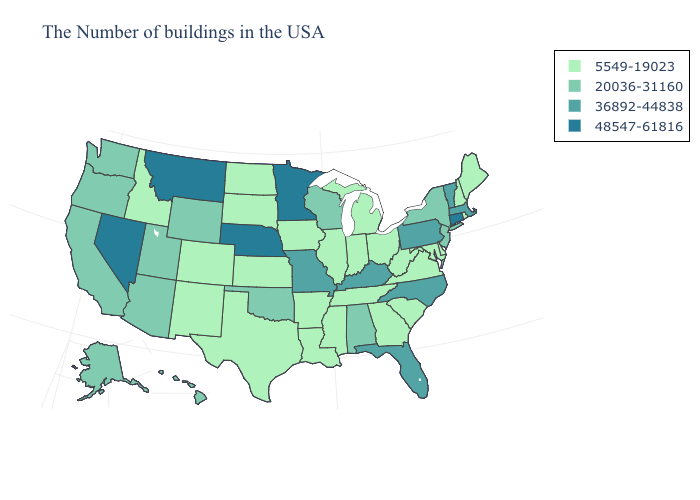Which states have the highest value in the USA?
Keep it brief. Connecticut, Minnesota, Nebraska, Montana, Nevada. What is the value of Maine?
Quick response, please. 5549-19023. Name the states that have a value in the range 36892-44838?
Keep it brief. Massachusetts, Vermont, Pennsylvania, North Carolina, Florida, Kentucky, Missouri. What is the lowest value in states that border Delaware?
Be succinct. 5549-19023. Does North Carolina have the lowest value in the South?
Be succinct. No. Which states have the lowest value in the West?
Quick response, please. Colorado, New Mexico, Idaho. Which states hav the highest value in the MidWest?
Short answer required. Minnesota, Nebraska. Name the states that have a value in the range 48547-61816?
Keep it brief. Connecticut, Minnesota, Nebraska, Montana, Nevada. Does New York have the same value as Hawaii?
Be succinct. Yes. Which states have the highest value in the USA?
Short answer required. Connecticut, Minnesota, Nebraska, Montana, Nevada. Does Florida have the highest value in the USA?
Be succinct. No. Does Texas have the highest value in the South?
Answer briefly. No. What is the highest value in the USA?
Concise answer only. 48547-61816. What is the value of North Carolina?
Short answer required. 36892-44838. Name the states that have a value in the range 36892-44838?
Answer briefly. Massachusetts, Vermont, Pennsylvania, North Carolina, Florida, Kentucky, Missouri. 